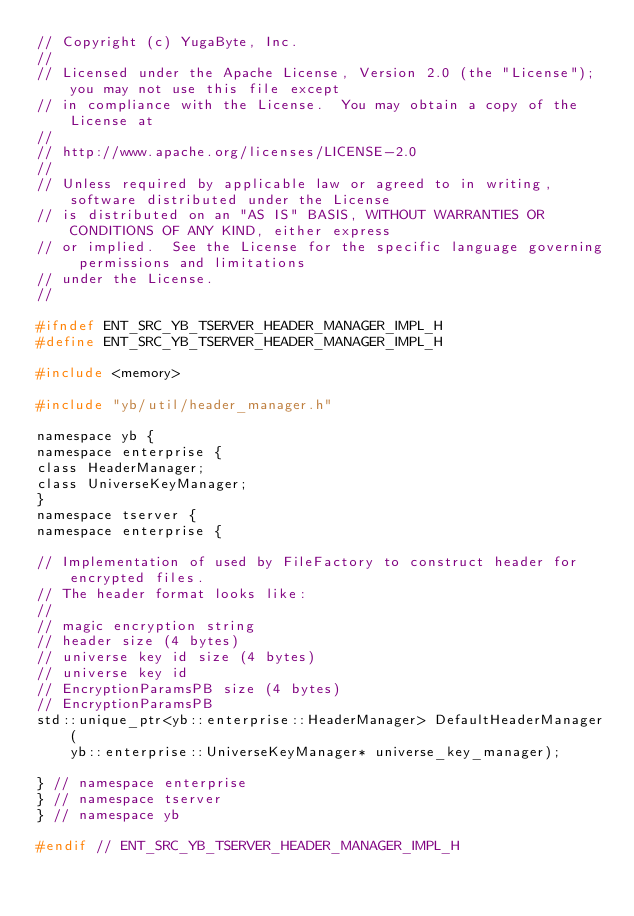<code> <loc_0><loc_0><loc_500><loc_500><_C_>// Copyright (c) YugaByte, Inc.
//
// Licensed under the Apache License, Version 2.0 (the "License"); you may not use this file except
// in compliance with the License.  You may obtain a copy of the License at
//
// http://www.apache.org/licenses/LICENSE-2.0
//
// Unless required by applicable law or agreed to in writing, software distributed under the License
// is distributed on an "AS IS" BASIS, WITHOUT WARRANTIES OR CONDITIONS OF ANY KIND, either express
// or implied.  See the License for the specific language governing permissions and limitations
// under the License.
//

#ifndef ENT_SRC_YB_TSERVER_HEADER_MANAGER_IMPL_H
#define ENT_SRC_YB_TSERVER_HEADER_MANAGER_IMPL_H

#include <memory>

#include "yb/util/header_manager.h"

namespace yb {
namespace enterprise {
class HeaderManager;
class UniverseKeyManager;
}
namespace tserver {
namespace enterprise {

// Implementation of used by FileFactory to construct header for encrypted files.
// The header format looks like:
//
// magic encryption string
// header size (4 bytes)
// universe key id size (4 bytes)
// universe key id
// EncryptionParamsPB size (4 bytes)
// EncryptionParamsPB
std::unique_ptr<yb::enterprise::HeaderManager> DefaultHeaderManager(
    yb::enterprise::UniverseKeyManager* universe_key_manager);

} // namespace enterprise
} // namespace tserver
} // namespace yb

#endif // ENT_SRC_YB_TSERVER_HEADER_MANAGER_IMPL_H
</code> 